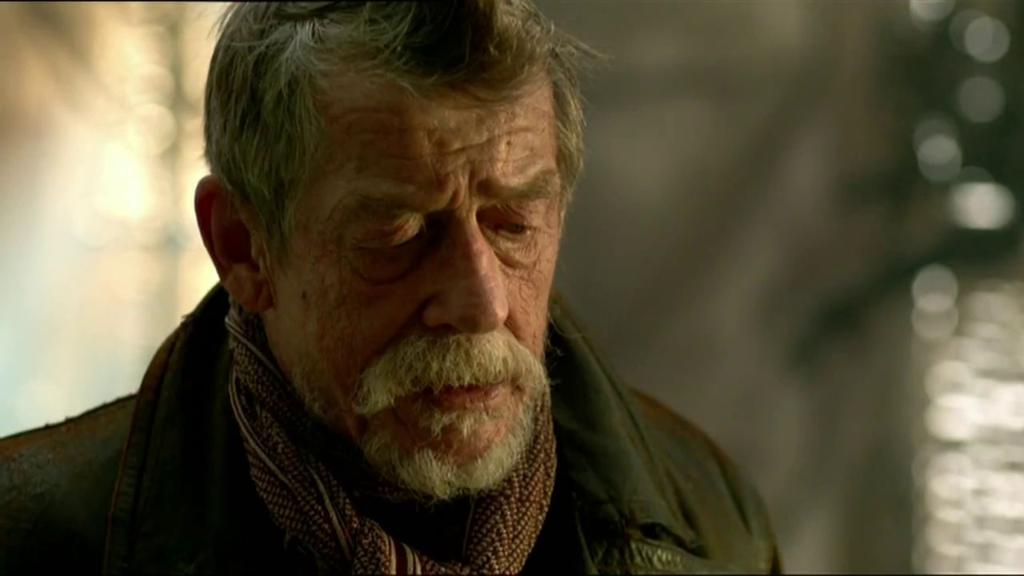What is the main subject of the image? There is a person in the image. Can you describe the background of the image? The background of the image is blurry. What type of shop can be seen in the background of the image? There is no shop present in the image; the background is blurry. What kind of joke is being told by the person in the image? There is no indication of a joke being told in the image, as it only features a person and a blurry background. 